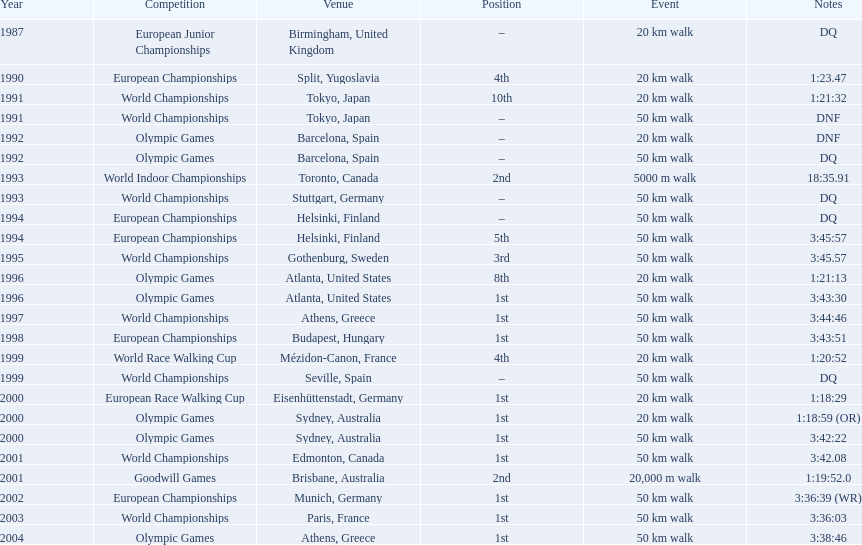Which of the contests involved 50 km walks? World Championships, Olympic Games, World Championships, European Championships, European Championships, World Championships, Olympic Games, World Championships, European Championships, World Championships, Olympic Games, World Championships, European Championships, World Championships, Olympic Games. Among them, which occurred in or after the year 2000? Olympic Games, World Championships, European Championships, World Championships, Olympic Games. From those, which happened in athens, greece? Olympic Games. What was the completion time for this event? 3:38:46. 